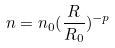Convert formula to latex. <formula><loc_0><loc_0><loc_500><loc_500>n = n _ { 0 } ( \frac { R } { R _ { 0 } } ) ^ { - p }</formula> 